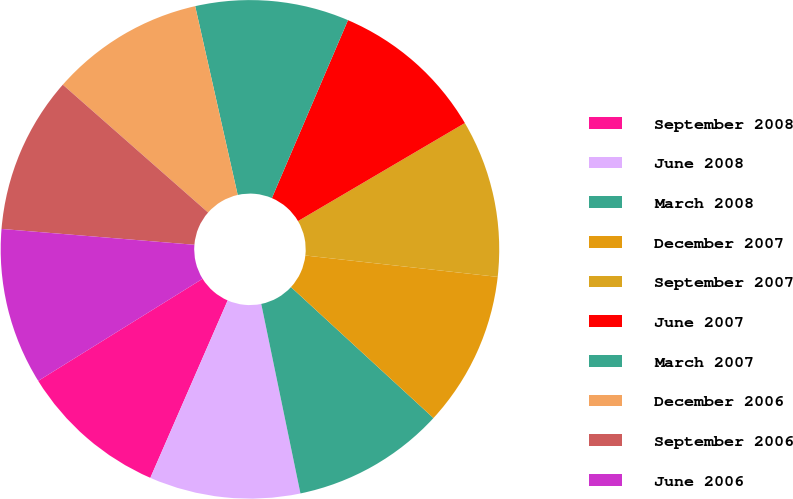<chart> <loc_0><loc_0><loc_500><loc_500><pie_chart><fcel>September 2008<fcel>June 2008<fcel>March 2008<fcel>December 2007<fcel>September 2007<fcel>June 2007<fcel>March 2007<fcel>December 2006<fcel>September 2006<fcel>June 2006<nl><fcel>9.61%<fcel>9.79%<fcel>9.92%<fcel>10.07%<fcel>10.22%<fcel>10.11%<fcel>9.96%<fcel>9.99%<fcel>10.18%<fcel>10.15%<nl></chart> 